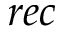<formula> <loc_0><loc_0><loc_500><loc_500>r e c</formula> 